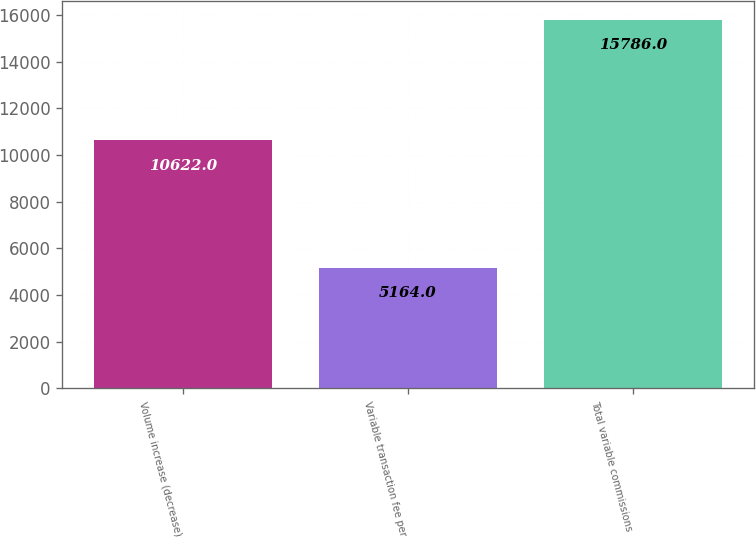Convert chart to OTSL. <chart><loc_0><loc_0><loc_500><loc_500><bar_chart><fcel>Volume increase (decrease)<fcel>Variable transaction fee per<fcel>Total variable commissions<nl><fcel>10622<fcel>5164<fcel>15786<nl></chart> 